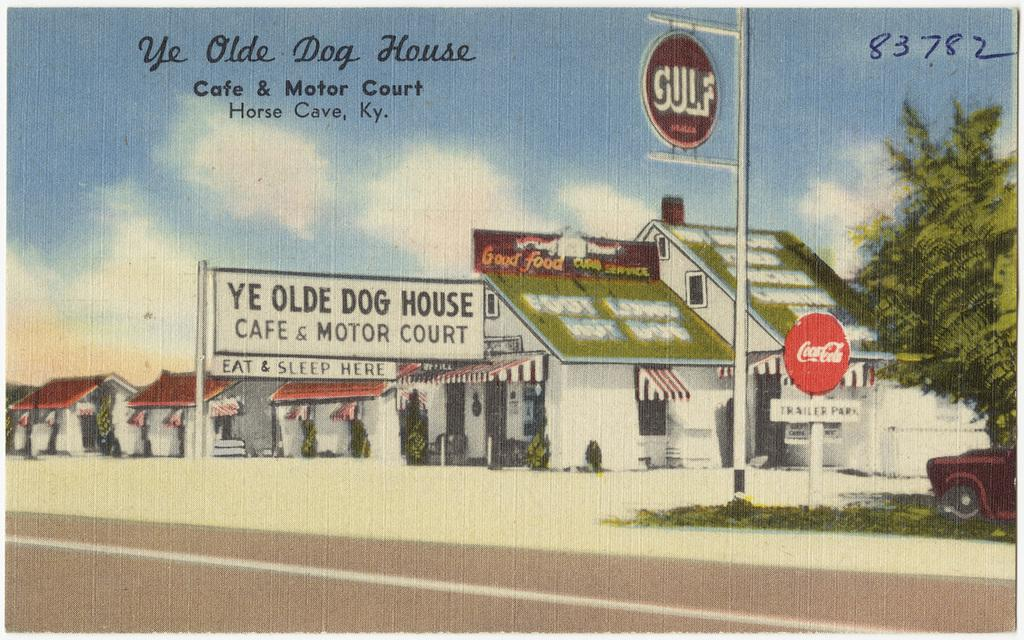<image>
Present a compact description of the photo's key features. The Ye Olde Dog House Cafe and Motor Court is in Horse Cave. 